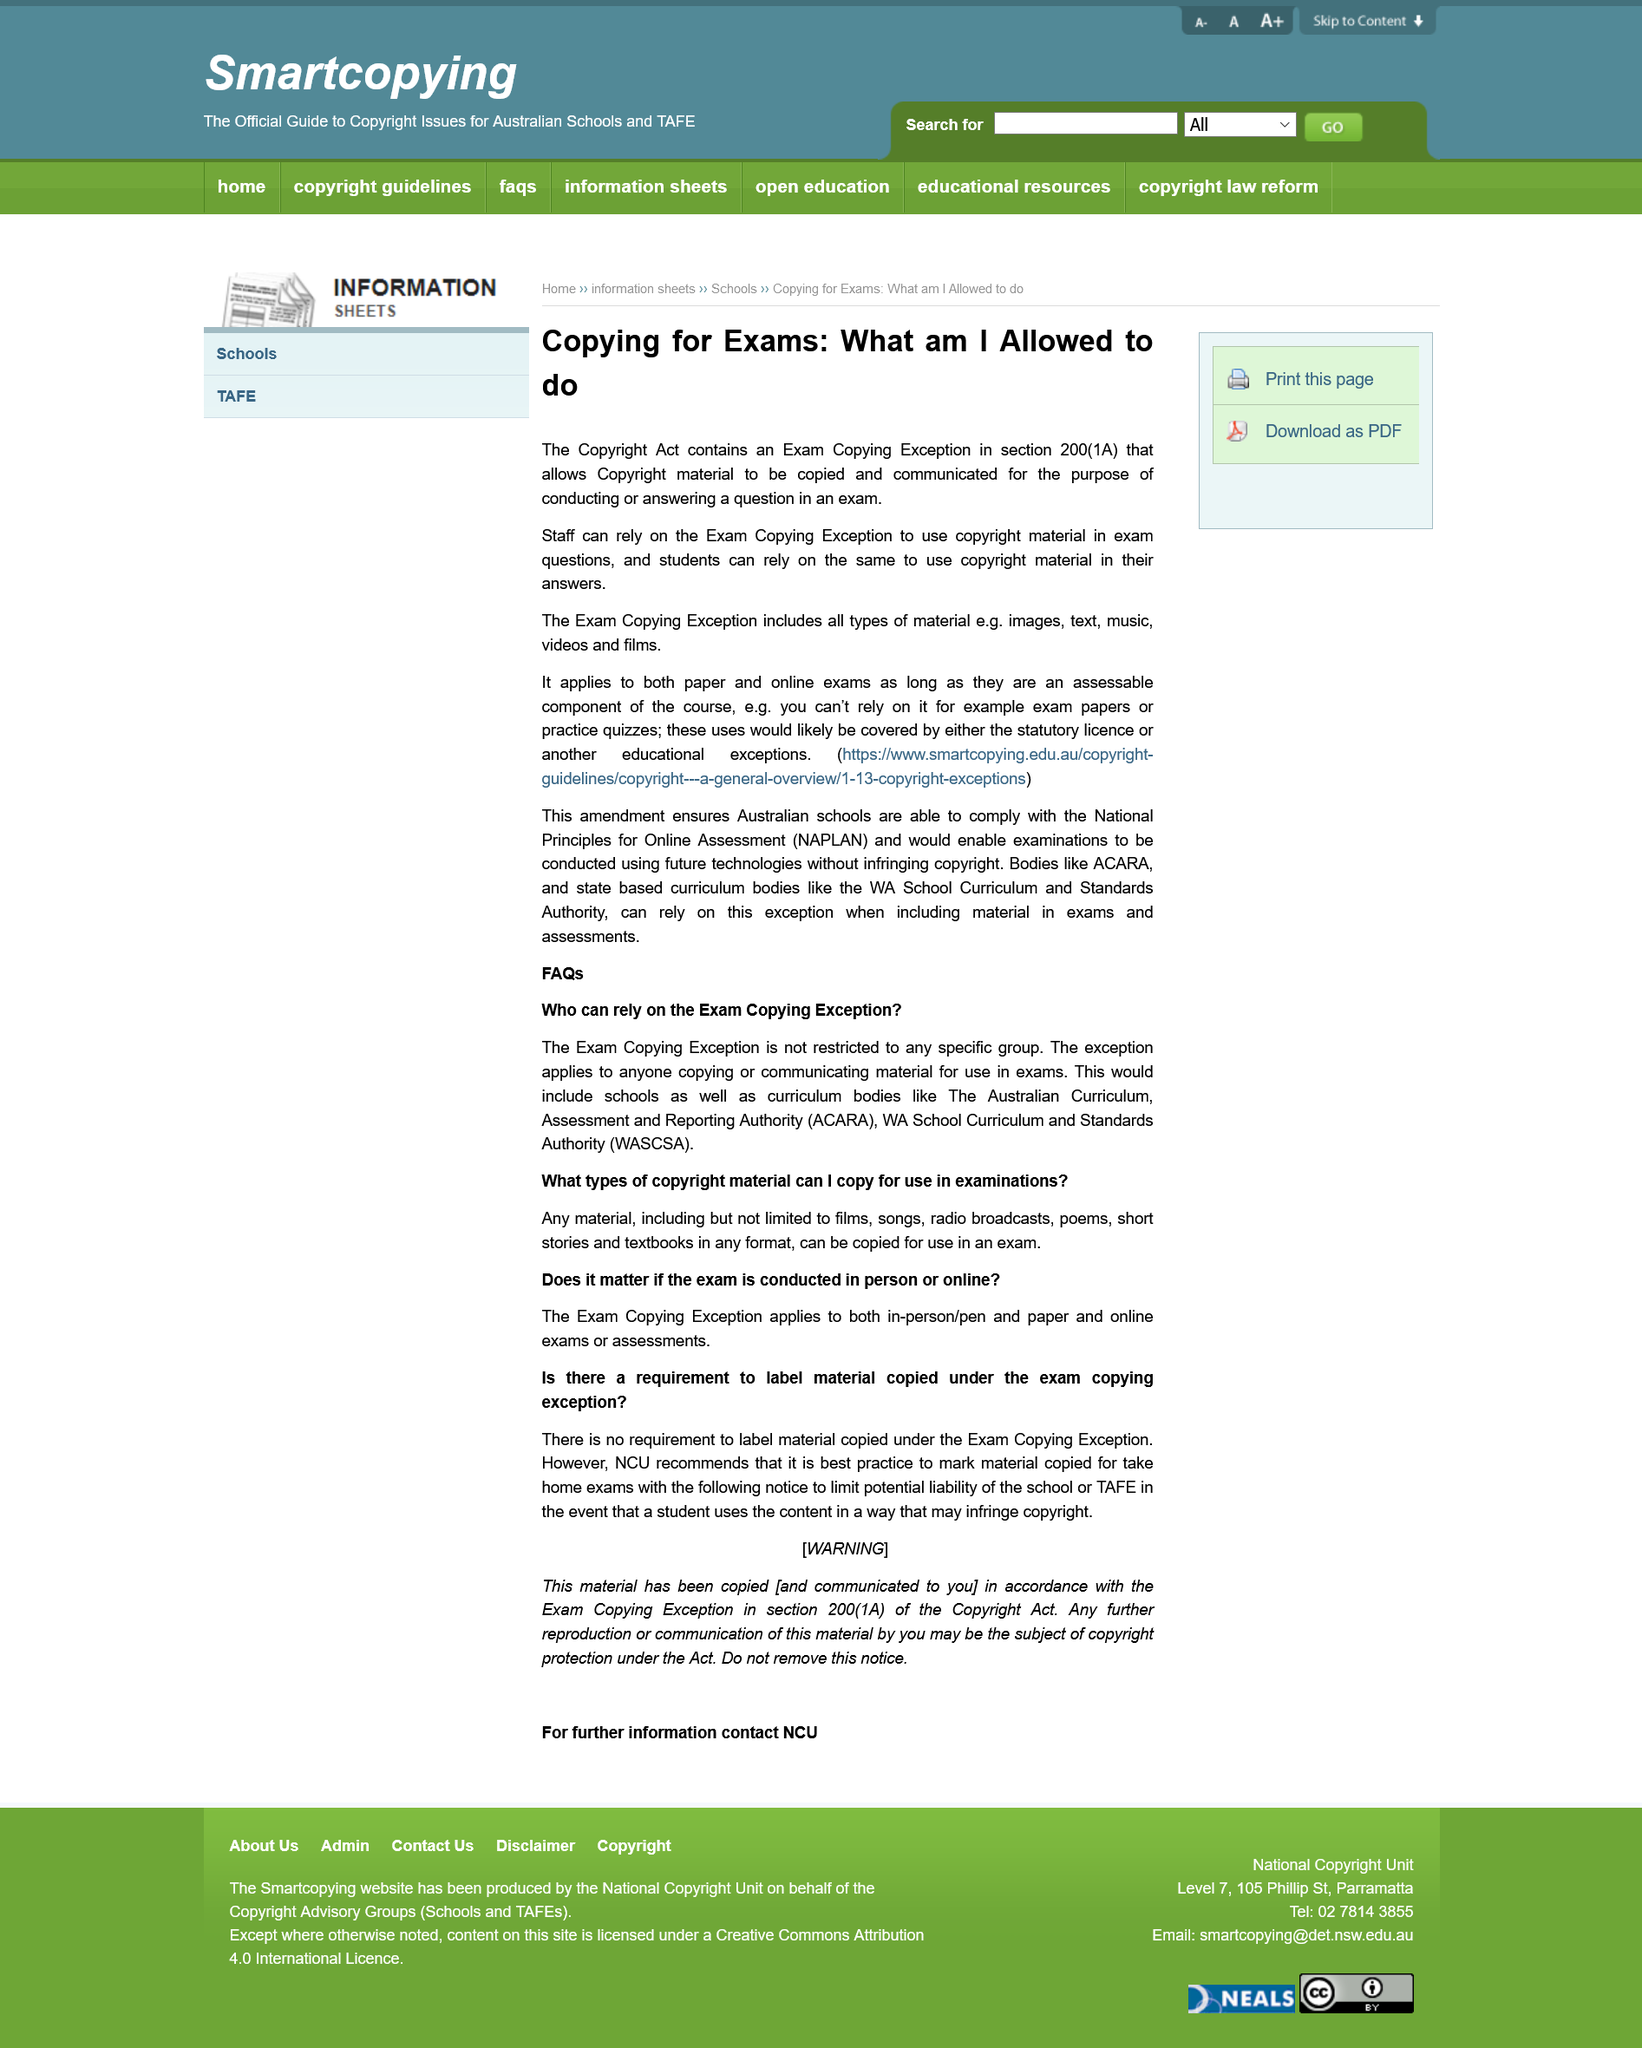Give some essential details in this illustration. The Exam Copying Exception in section 200(1A) of the Copyright Act permits students to use copyright material in their answers. The Exam Copying Exception is not restricted to any specific group. The Exam Copying Exception covers all types of material. It is not necessary to label material copied under the exam copying exception. Yes, staff can use the Exam Copying Exception to include copyright material in exam questions. 